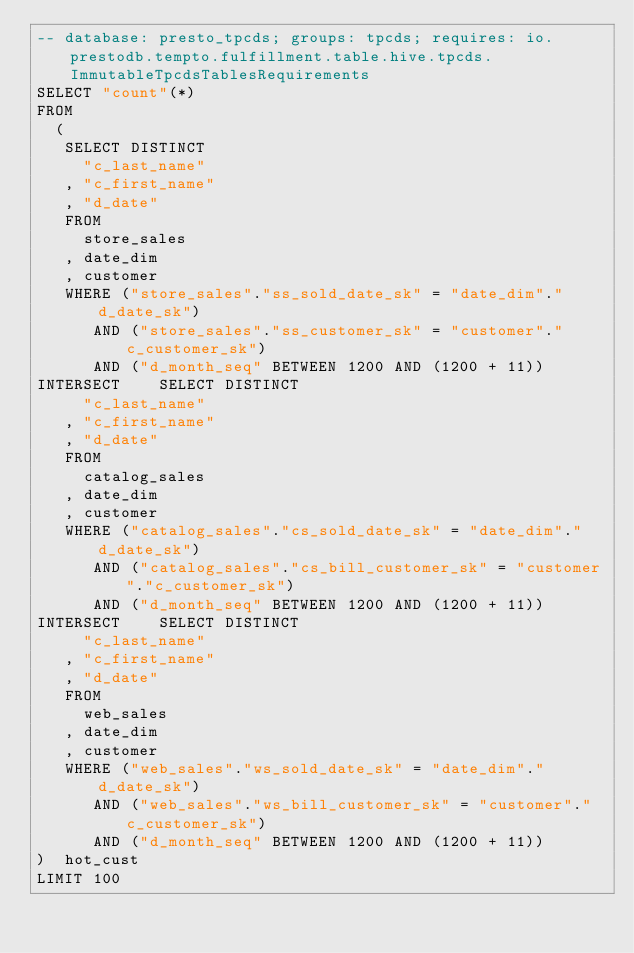Convert code to text. <code><loc_0><loc_0><loc_500><loc_500><_SQL_>-- database: presto_tpcds; groups: tpcds; requires: io.prestodb.tempto.fulfillment.table.hive.tpcds.ImmutableTpcdsTablesRequirements
SELECT "count"(*)
FROM
  (
   SELECT DISTINCT
     "c_last_name"
   , "c_first_name"
   , "d_date"
   FROM
     store_sales
   , date_dim
   , customer
   WHERE ("store_sales"."ss_sold_date_sk" = "date_dim"."d_date_sk")
      AND ("store_sales"."ss_customer_sk" = "customer"."c_customer_sk")
      AND ("d_month_seq" BETWEEN 1200 AND (1200 + 11))
INTERSECT    SELECT DISTINCT
     "c_last_name"
   , "c_first_name"
   , "d_date"
   FROM
     catalog_sales
   , date_dim
   , customer
   WHERE ("catalog_sales"."cs_sold_date_sk" = "date_dim"."d_date_sk")
      AND ("catalog_sales"."cs_bill_customer_sk" = "customer"."c_customer_sk")
      AND ("d_month_seq" BETWEEN 1200 AND (1200 + 11))
INTERSECT    SELECT DISTINCT
     "c_last_name"
   , "c_first_name"
   , "d_date"
   FROM
     web_sales
   , date_dim
   , customer
   WHERE ("web_sales"."ws_sold_date_sk" = "date_dim"."d_date_sk")
      AND ("web_sales"."ws_bill_customer_sk" = "customer"."c_customer_sk")
      AND ("d_month_seq" BETWEEN 1200 AND (1200 + 11))
)  hot_cust
LIMIT 100
</code> 